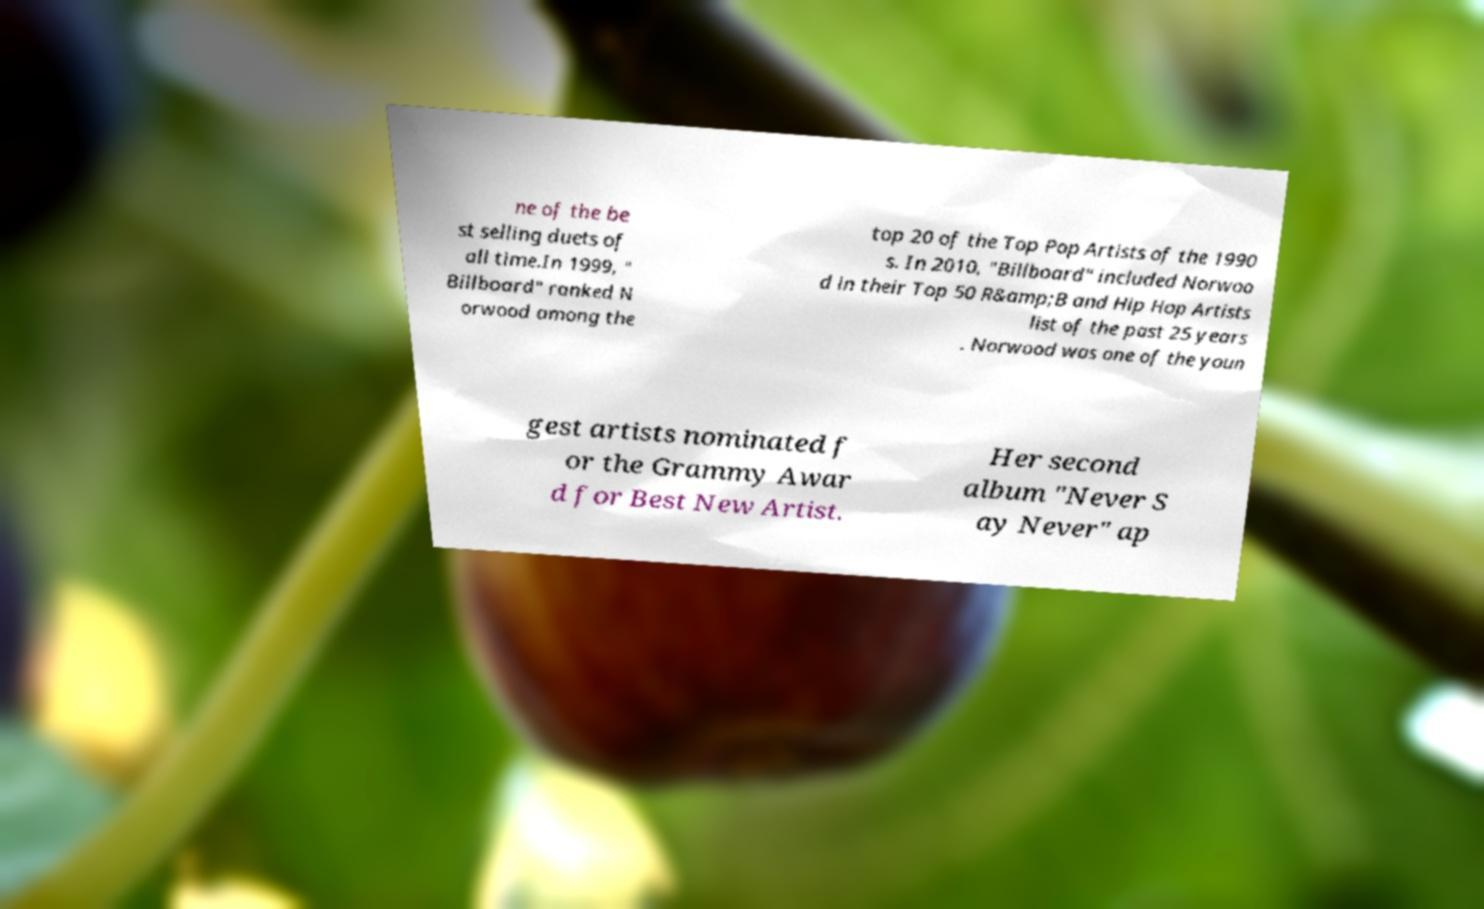Could you extract and type out the text from this image? ne of the be st selling duets of all time.In 1999, " Billboard" ranked N orwood among the top 20 of the Top Pop Artists of the 1990 s. In 2010, "Billboard" included Norwoo d in their Top 50 R&amp;B and Hip Hop Artists list of the past 25 years . Norwood was one of the youn gest artists nominated f or the Grammy Awar d for Best New Artist. Her second album "Never S ay Never" ap 